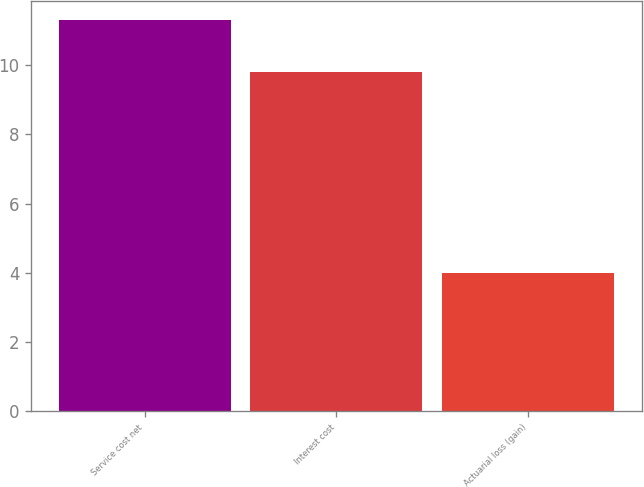<chart> <loc_0><loc_0><loc_500><loc_500><bar_chart><fcel>Service cost net<fcel>Interest cost<fcel>Actuarial loss (gain)<nl><fcel>11.3<fcel>9.8<fcel>4<nl></chart> 